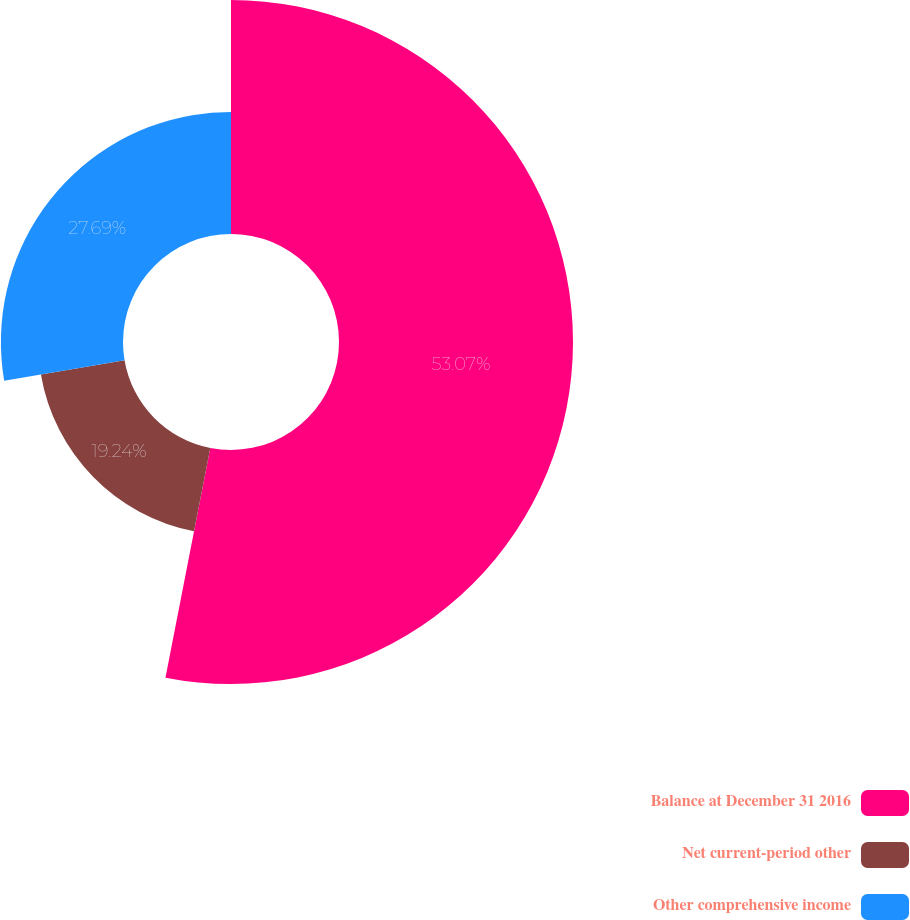<chart> <loc_0><loc_0><loc_500><loc_500><pie_chart><fcel>Balance at December 31 2016<fcel>Net current-period other<fcel>Other comprehensive income<nl><fcel>53.07%<fcel>19.24%<fcel>27.69%<nl></chart> 